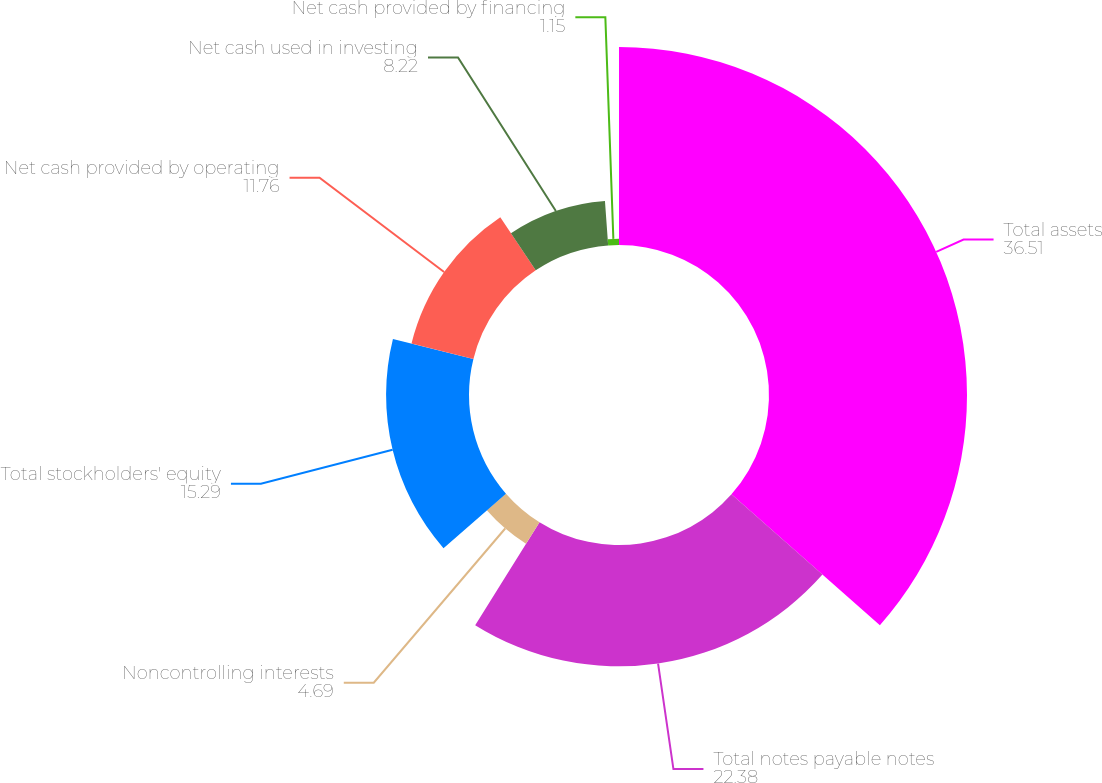Convert chart to OTSL. <chart><loc_0><loc_0><loc_500><loc_500><pie_chart><fcel>Total assets<fcel>Total notes payable notes<fcel>Noncontrolling interests<fcel>Total stockholders' equity<fcel>Net cash provided by operating<fcel>Net cash used in investing<fcel>Net cash provided by financing<nl><fcel>36.51%<fcel>22.38%<fcel>4.69%<fcel>15.29%<fcel>11.76%<fcel>8.22%<fcel>1.15%<nl></chart> 